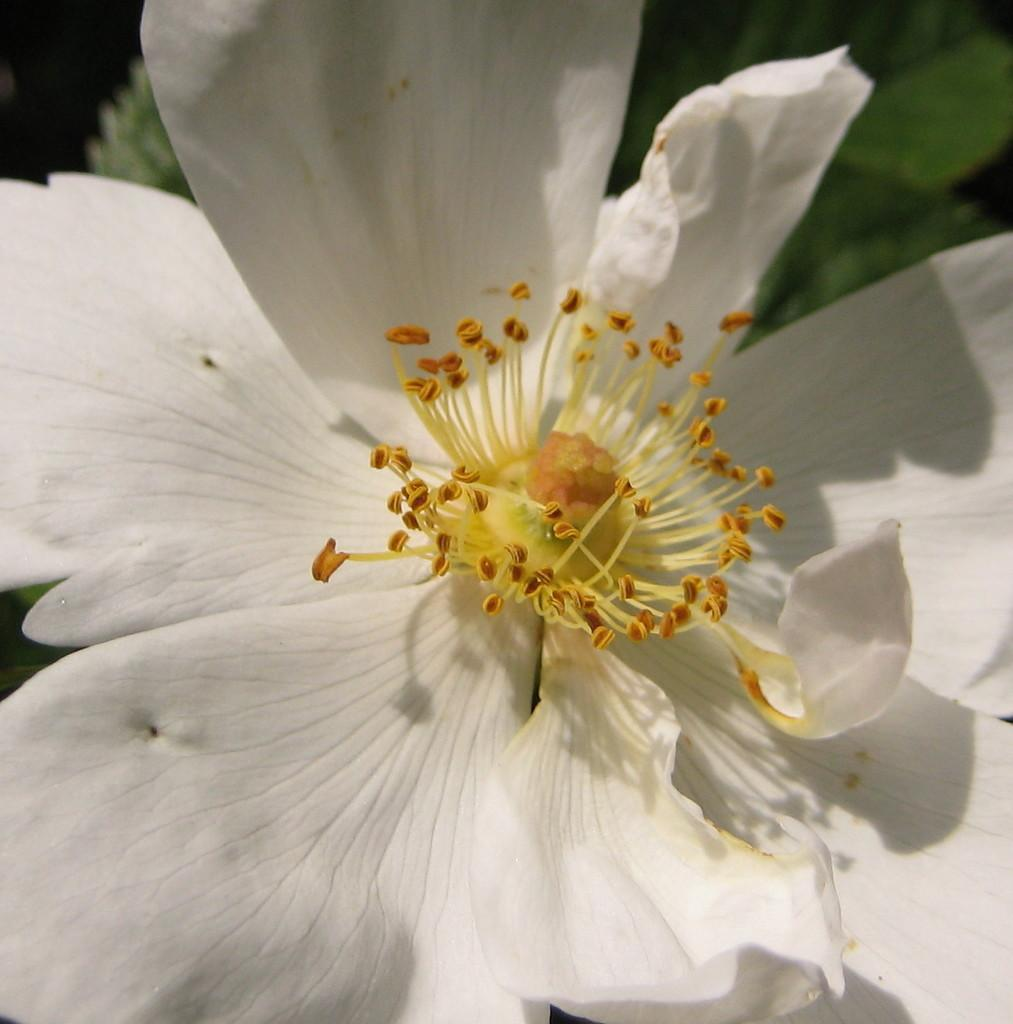What is the main subject of the image? There is a flower in the image. Can you describe the background of the image? The background of the image is blurry. What type of vacation is the flower planning for next year? There is no indication in the image that the flower is planning a vacation, as flowers do not have the ability to plan vacations. 